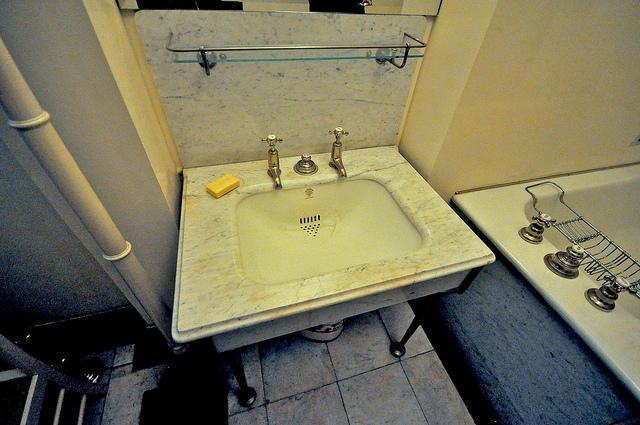How many sinks are visible?
Give a very brief answer. 1. How many birds are in the background?
Give a very brief answer. 0. 